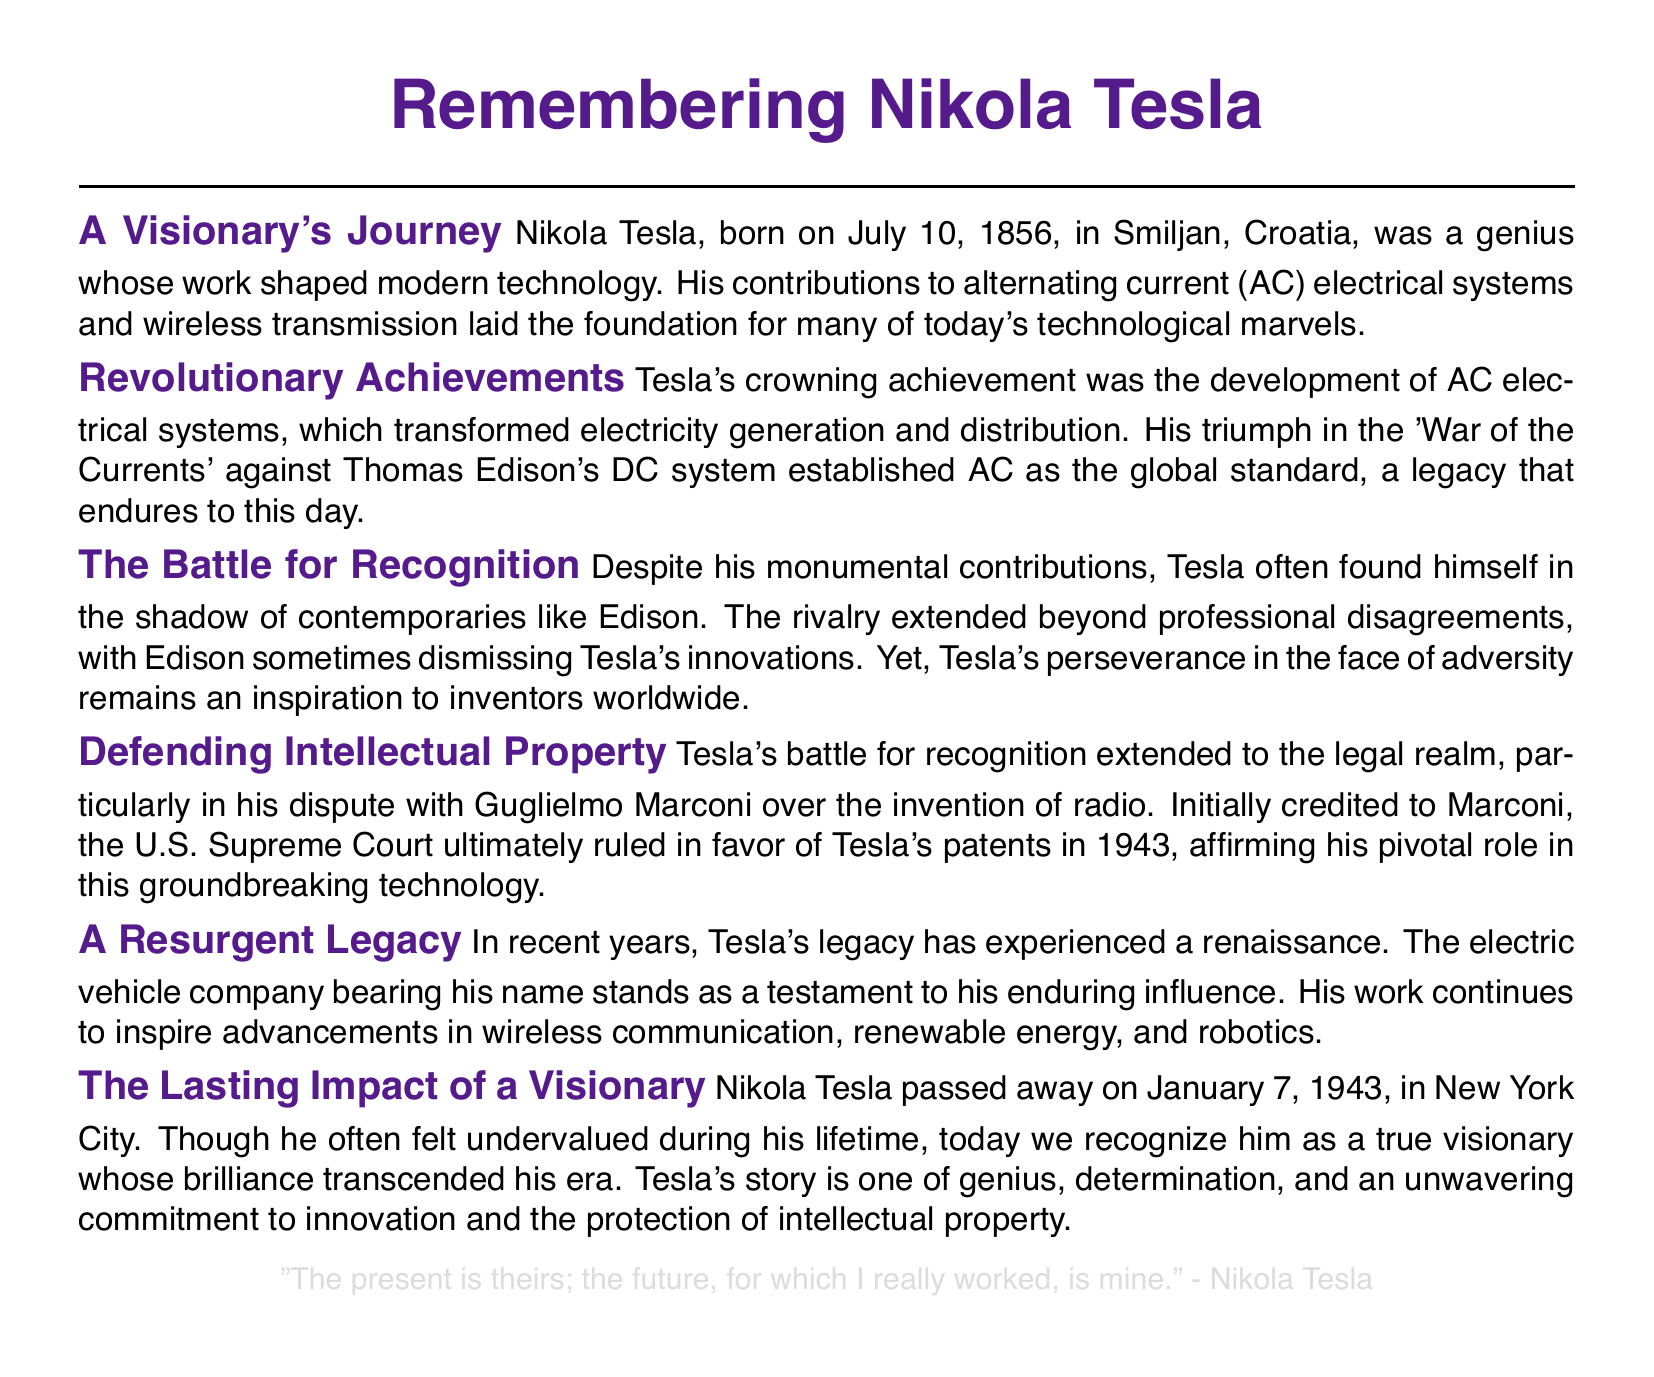What date was Nikola Tesla born? The document states that Nikola Tesla was born on July 10, 1856.
Answer: July 10, 1856 What is Tesla's most famous achievement? The document highlights that Tesla's crowning achievement was the development of AC electrical systems.
Answer: AC electrical systems Who did Tesla compete against in the 'War of the Currents'? The document mentions that Tesla competed against Thomas Edison in the 'War of the Currents.'
Answer: Thomas Edison What significant legal ruling occurred in 1943? The document indicates that the U.S. Supreme Court ruled in favor of Tesla's patents in 1943.
Answer: Tesla's patents What company is named after Tesla in recent years? The document references an electric vehicle company that bears Tesla's name.
Answer: Tesla What is a major theme of Tesla's legacy discussed in the document? The document notes that a major theme of Tesla's legacy is the battle for recognition and the protection of intellectual property.
Answer: Protection of intellectual property What year did Nikola Tesla die? According to the document, Nikola Tesla passed away on January 7, 1943.
Answer: January 7, 1943 What does Tesla's quote in the document signify? The document's quote signifies Tesla's belief that while contemporary recognition may be fleeting, his future contributions endure.
Answer: Future contributions endure How is Tesla's story described in the eulogy? The document describes Tesla's story as one of genius, determination, and an unwavering commitment to innovation.
Answer: Genius, determination, and commitment to innovation 